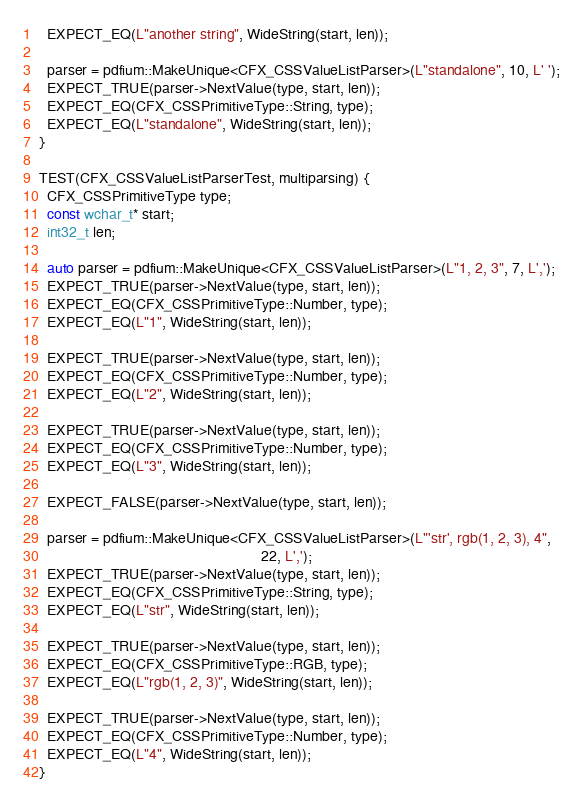Convert code to text. <code><loc_0><loc_0><loc_500><loc_500><_C++_>  EXPECT_EQ(L"another string", WideString(start, len));

  parser = pdfium::MakeUnique<CFX_CSSValueListParser>(L"standalone", 10, L' ');
  EXPECT_TRUE(parser->NextValue(type, start, len));
  EXPECT_EQ(CFX_CSSPrimitiveType::String, type);
  EXPECT_EQ(L"standalone", WideString(start, len));
}

TEST(CFX_CSSValueListParserTest, multiparsing) {
  CFX_CSSPrimitiveType type;
  const wchar_t* start;
  int32_t len;

  auto parser = pdfium::MakeUnique<CFX_CSSValueListParser>(L"1, 2, 3", 7, L',');
  EXPECT_TRUE(parser->NextValue(type, start, len));
  EXPECT_EQ(CFX_CSSPrimitiveType::Number, type);
  EXPECT_EQ(L"1", WideString(start, len));

  EXPECT_TRUE(parser->NextValue(type, start, len));
  EXPECT_EQ(CFX_CSSPrimitiveType::Number, type);
  EXPECT_EQ(L"2", WideString(start, len));

  EXPECT_TRUE(parser->NextValue(type, start, len));
  EXPECT_EQ(CFX_CSSPrimitiveType::Number, type);
  EXPECT_EQ(L"3", WideString(start, len));

  EXPECT_FALSE(parser->NextValue(type, start, len));

  parser = pdfium::MakeUnique<CFX_CSSValueListParser>(L"'str', rgb(1, 2, 3), 4",
                                                      22, L',');
  EXPECT_TRUE(parser->NextValue(type, start, len));
  EXPECT_EQ(CFX_CSSPrimitiveType::String, type);
  EXPECT_EQ(L"str", WideString(start, len));

  EXPECT_TRUE(parser->NextValue(type, start, len));
  EXPECT_EQ(CFX_CSSPrimitiveType::RGB, type);
  EXPECT_EQ(L"rgb(1, 2, 3)", WideString(start, len));

  EXPECT_TRUE(parser->NextValue(type, start, len));
  EXPECT_EQ(CFX_CSSPrimitiveType::Number, type);
  EXPECT_EQ(L"4", WideString(start, len));
}
</code> 